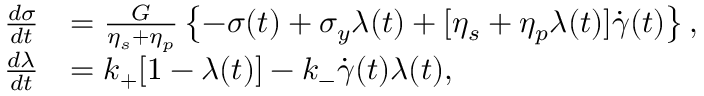<formula> <loc_0><loc_0><loc_500><loc_500>\begin{array} { r l } { \frac { d \sigma } { d t } } & { = \frac { G } { \eta _ { s } + \eta _ { p } } \left \{ - \sigma ( t ) + \sigma _ { y } \lambda ( t ) + [ \eta _ { s } + \eta _ { p } \lambda ( t ) ] \dot { \gamma } ( t ) \right \} , } \\ { \frac { d \lambda } { d t } } & { = k _ { + } [ 1 - \lambda ( t ) ] - k _ { - } \dot { \gamma } ( t ) \lambda ( t ) , } \end{array}</formula> 